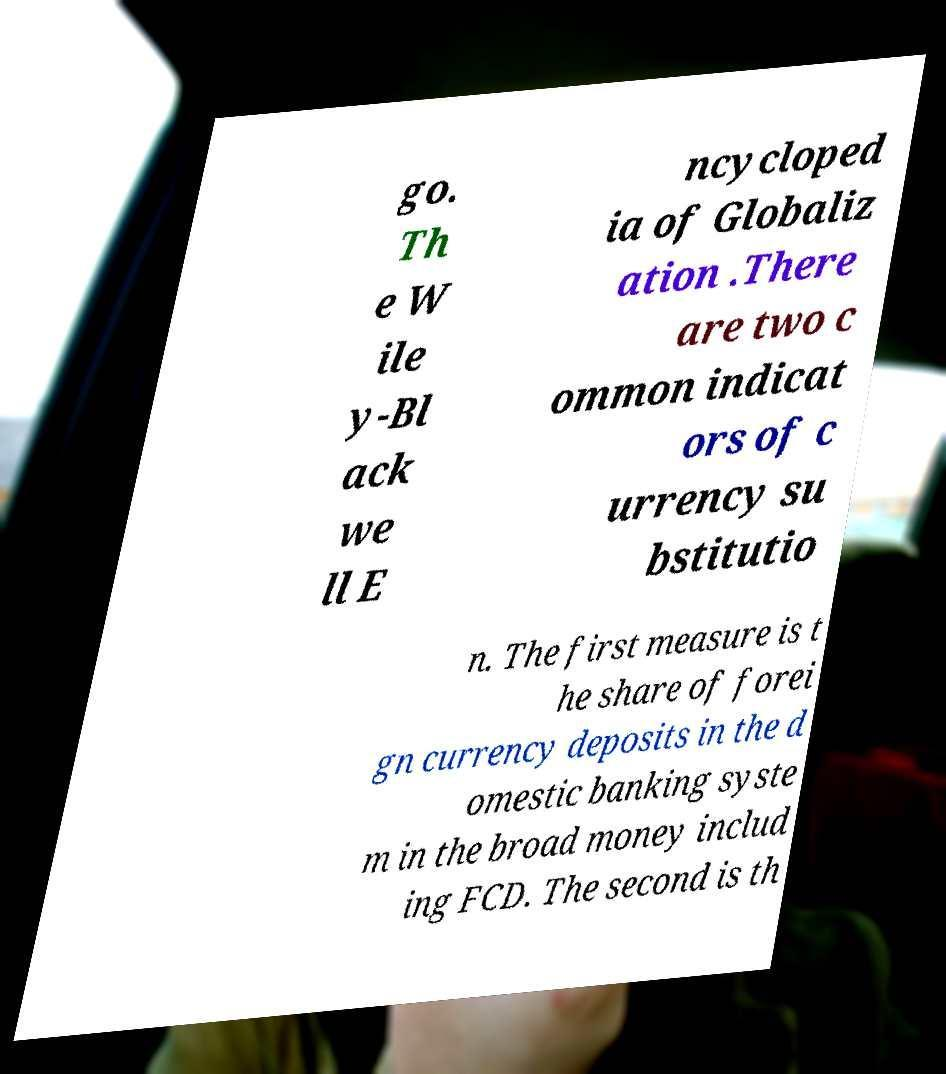Please read and relay the text visible in this image. What does it say? go. Th e W ile y-Bl ack we ll E ncycloped ia of Globaliz ation .There are two c ommon indicat ors of c urrency su bstitutio n. The first measure is t he share of forei gn currency deposits in the d omestic banking syste m in the broad money includ ing FCD. The second is th 